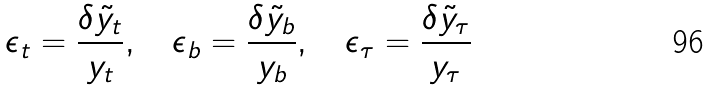<formula> <loc_0><loc_0><loc_500><loc_500>\epsilon _ { t } = \frac { \delta \tilde { y } _ { t } } { y _ { t } } , \quad \epsilon _ { b } = \frac { \delta \tilde { y } _ { b } } { y _ { b } } , \quad \epsilon _ { \tau } = \frac { \delta \tilde { y } _ { \tau } } { y _ { \tau } }</formula> 